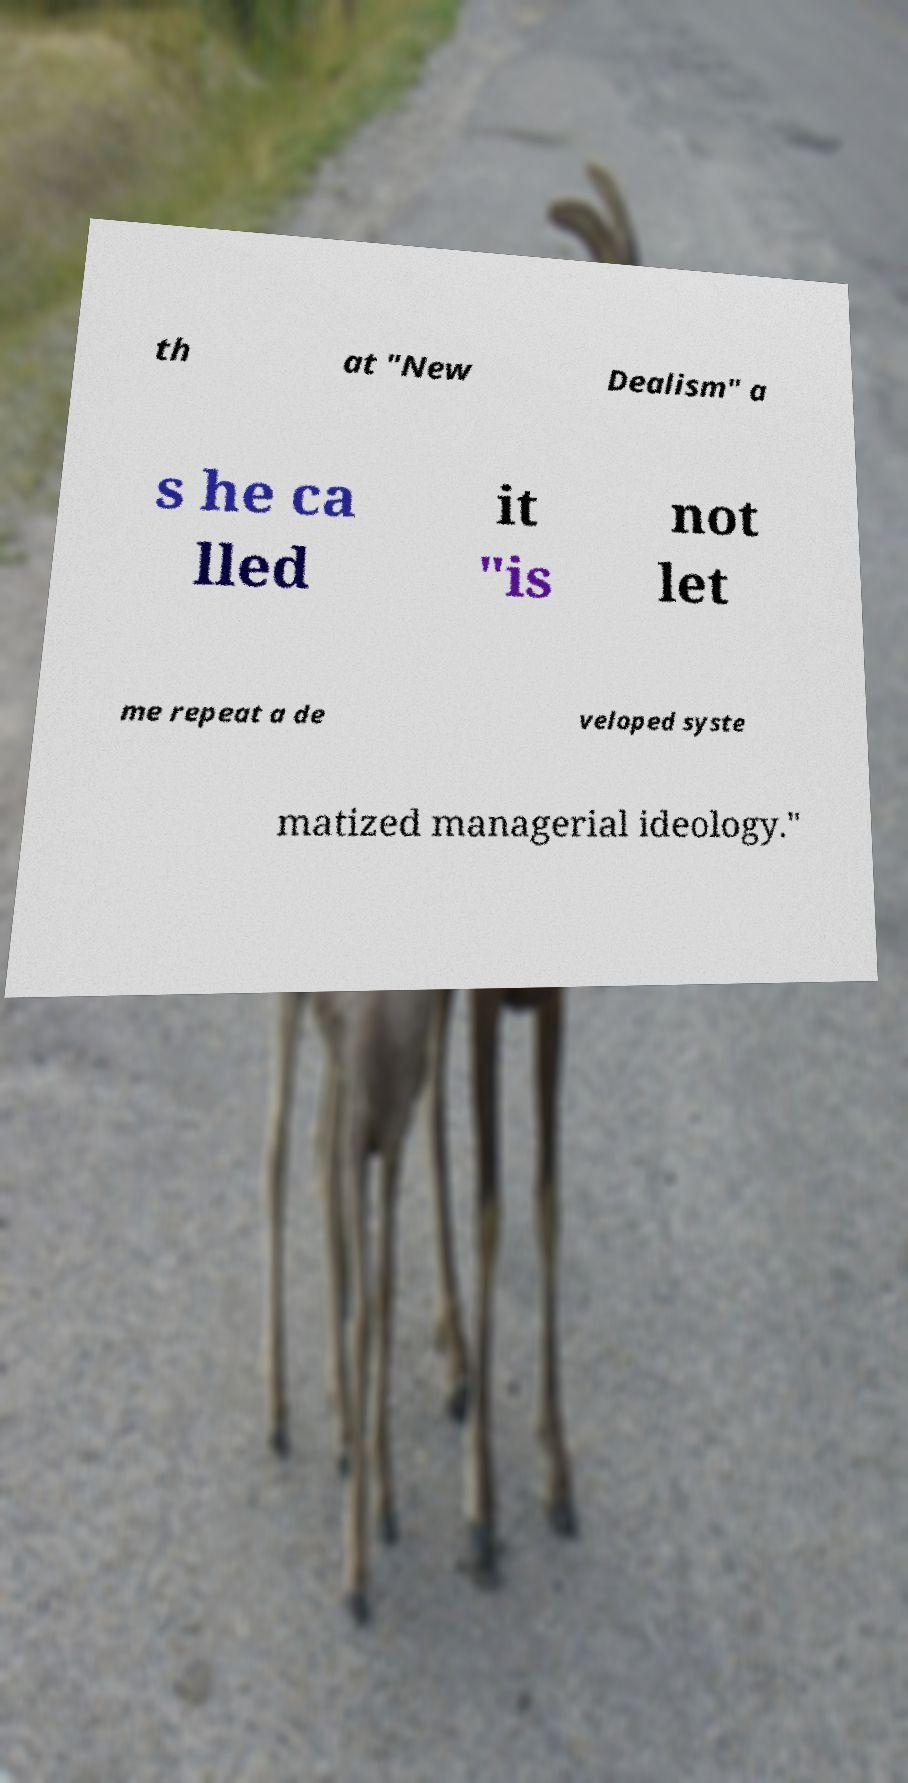I need the written content from this picture converted into text. Can you do that? th at "New Dealism" a s he ca lled it "is not let me repeat a de veloped syste matized managerial ideology." 